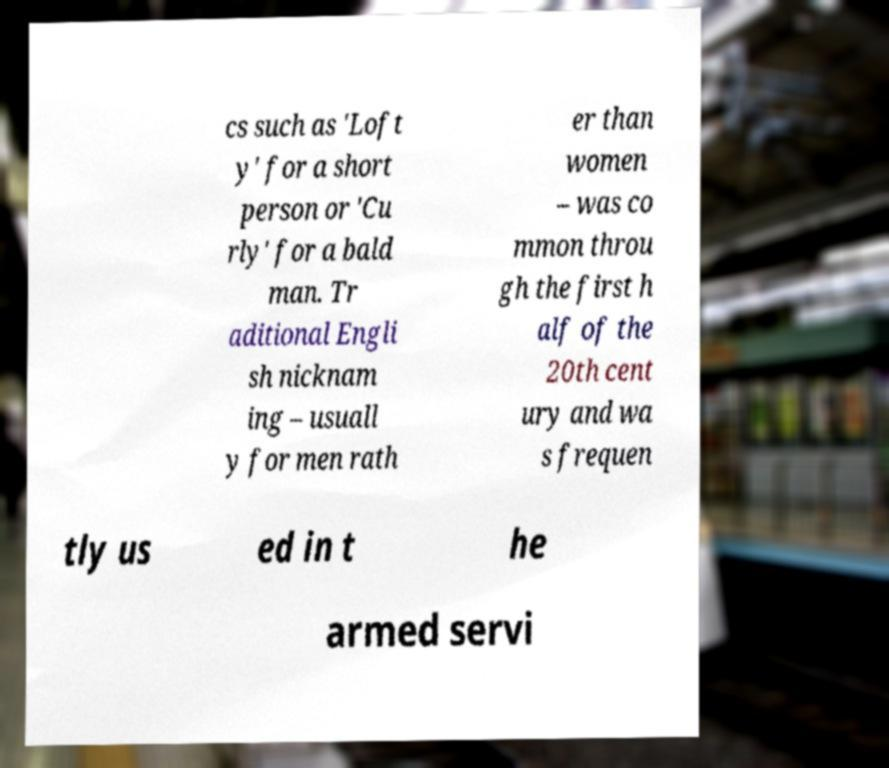There's text embedded in this image that I need extracted. Can you transcribe it verbatim? cs such as 'Loft y' for a short person or 'Cu rly' for a bald man. Tr aditional Engli sh nicknam ing – usuall y for men rath er than women – was co mmon throu gh the first h alf of the 20th cent ury and wa s frequen tly us ed in t he armed servi 